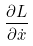<formula> <loc_0><loc_0><loc_500><loc_500>\frac { \partial L } { \partial \dot { x } }</formula> 